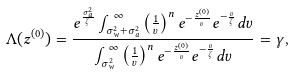Convert formula to latex. <formula><loc_0><loc_0><loc_500><loc_500>\Lambda ( z ^ { ( 0 ) } ) & = \frac { e ^ { \frac { \sigma _ { a } ^ { 2 } } { \zeta } } \int _ { \sigma _ { w } ^ { 2 } + \sigma _ { a } ^ { 2 } } ^ { \infty } \left ( \frac { 1 } { v } \right ) ^ { n } e ^ { - \frac { z ^ { ( 0 ) } } { v } } e ^ { - \frac { v } { \zeta } } d v } { \int _ { \sigma _ { w } ^ { 2 } } ^ { \infty } \left ( \frac { 1 } { v } \right ) ^ { n } e ^ { - \frac { z ^ { ( 0 ) } } { v } } e ^ { - \frac { v } { \zeta } } d v } = \gamma ,</formula> 